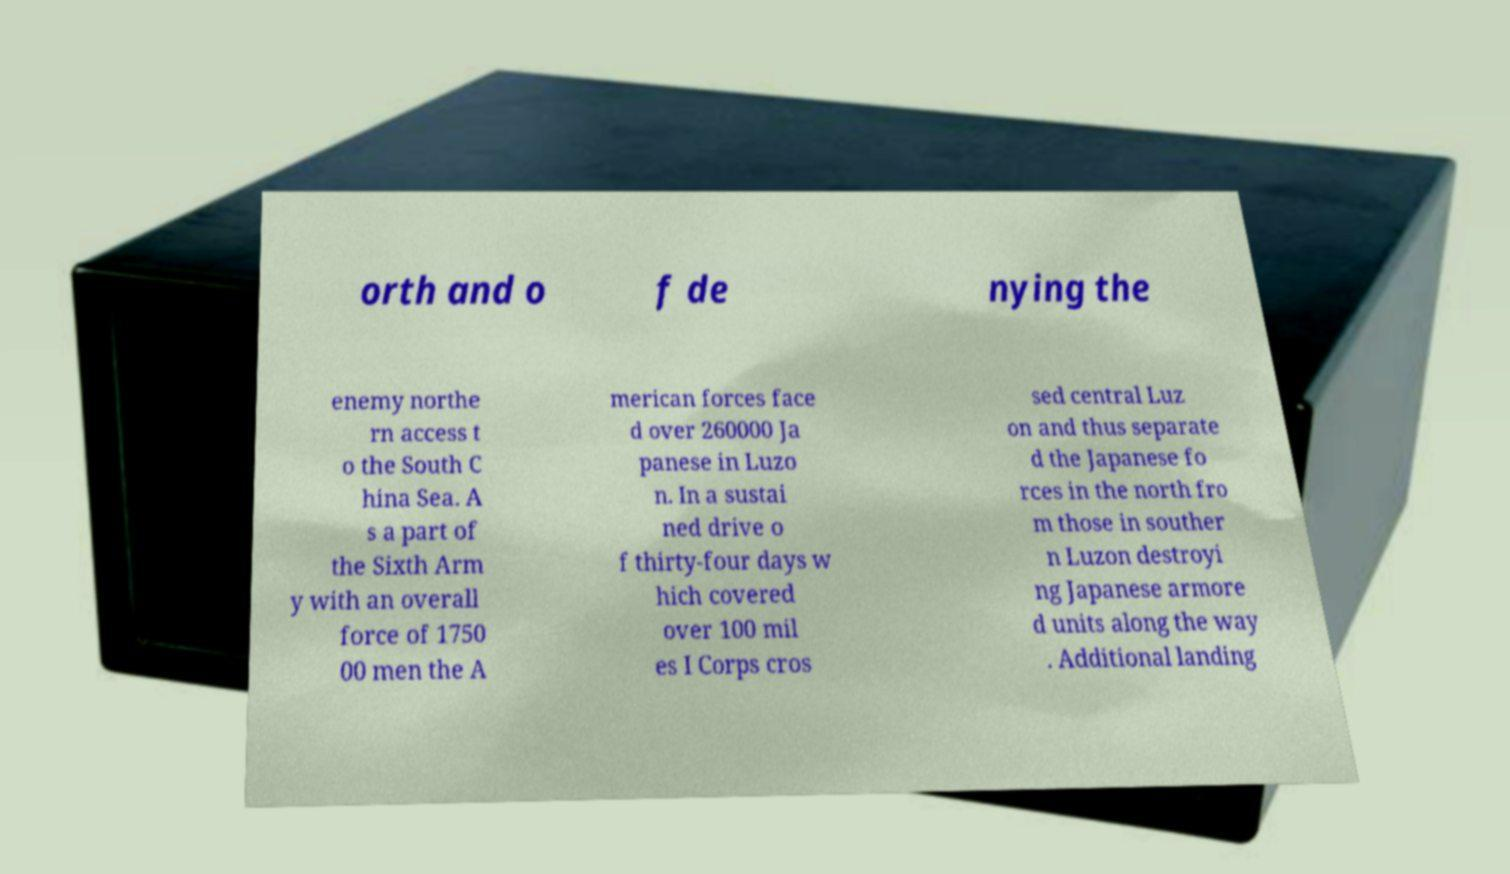Please read and relay the text visible in this image. What does it say? orth and o f de nying the enemy northe rn access t o the South C hina Sea. A s a part of the Sixth Arm y with an overall force of 1750 00 men the A merican forces face d over 260000 Ja panese in Luzo n. In a sustai ned drive o f thirty-four days w hich covered over 100 mil es I Corps cros sed central Luz on and thus separate d the Japanese fo rces in the north fro m those in souther n Luzon destroyi ng Japanese armore d units along the way . Additional landing 